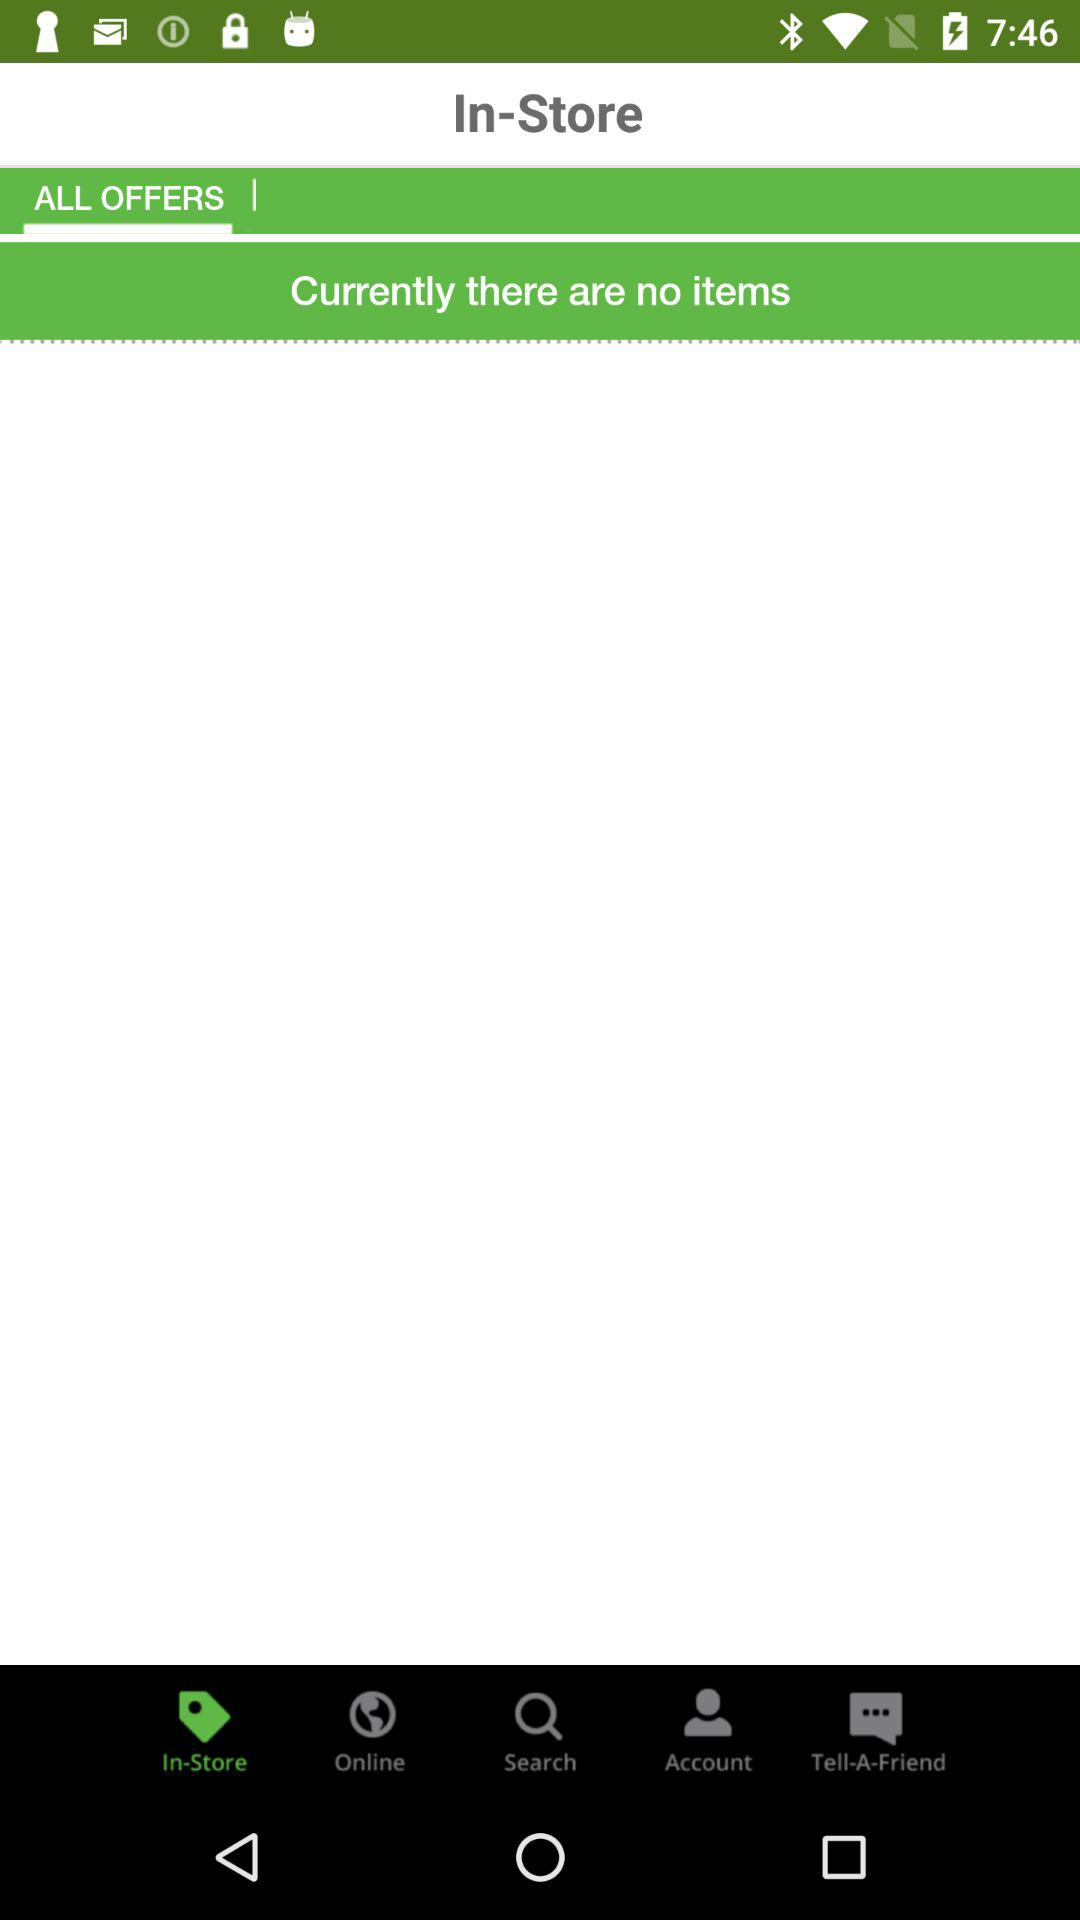Is there any item in the store? There are no items in the store. 